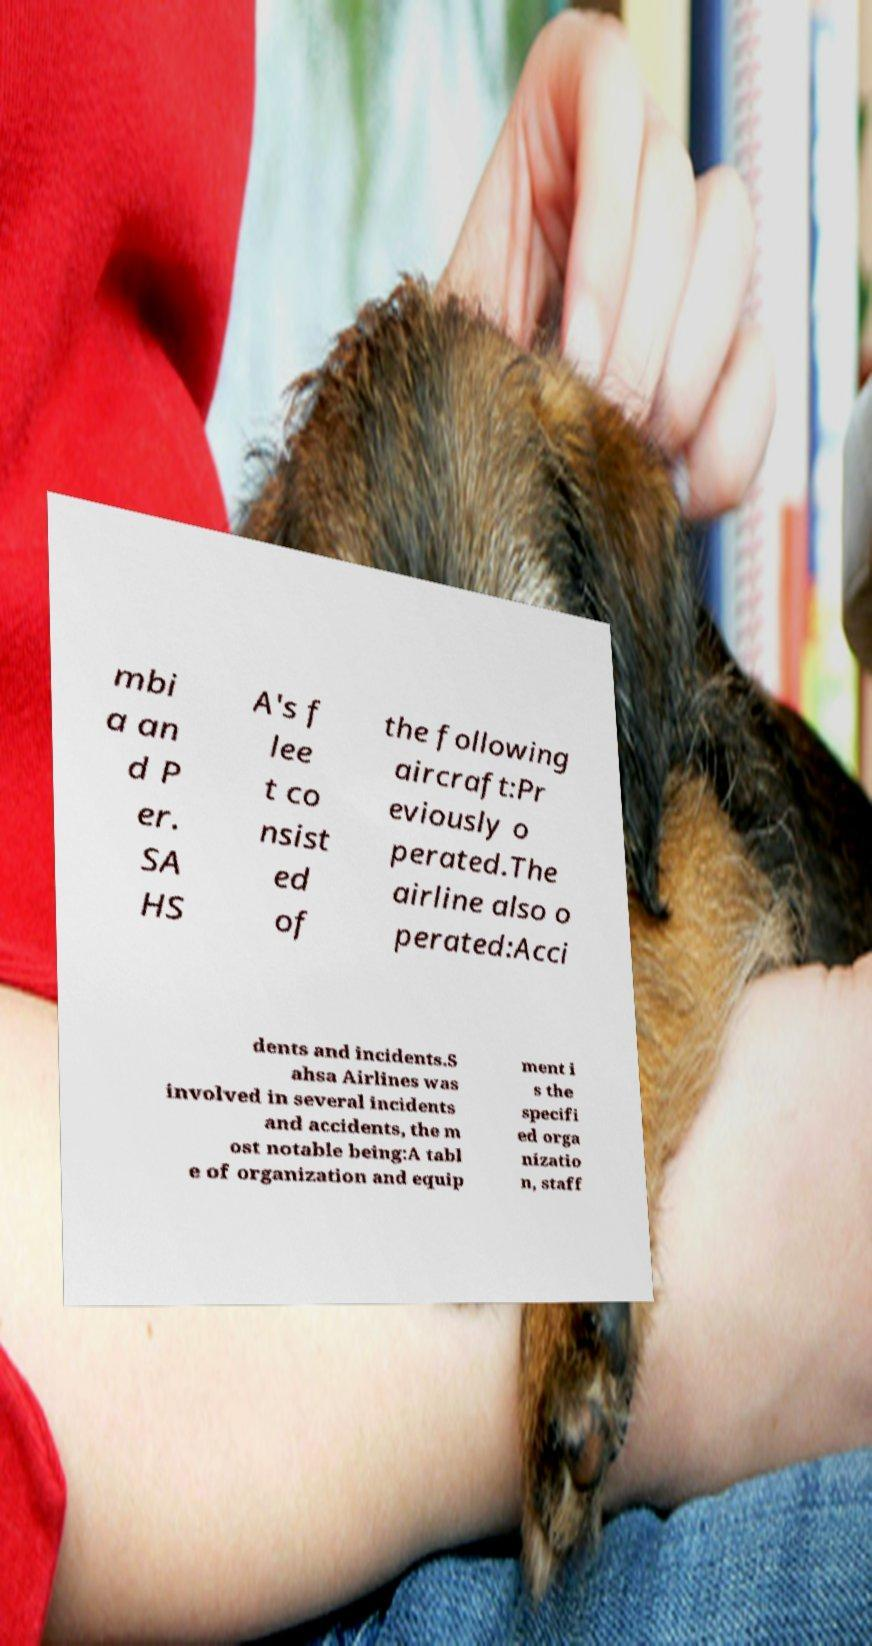Please read and relay the text visible in this image. What does it say? mbi a an d P er. SA HS A's f lee t co nsist ed of the following aircraft:Pr eviously o perated.The airline also o perated:Acci dents and incidents.S ahsa Airlines was involved in several incidents and accidents, the m ost notable being:A tabl e of organization and equip ment i s the specifi ed orga nizatio n, staff 